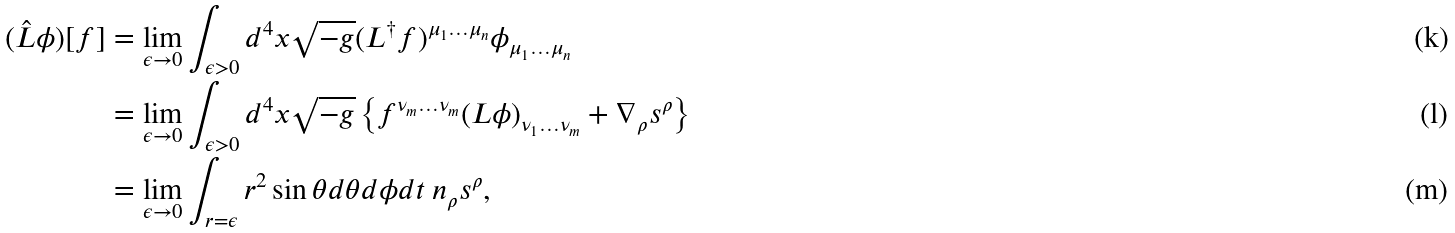Convert formula to latex. <formula><loc_0><loc_0><loc_500><loc_500>( \hat { L } \phi ) [ f ] & = \lim _ { \epsilon \rightarrow 0 } \int _ { \epsilon > 0 } d ^ { 4 } x \sqrt { - g } ( L ^ { \dagger } f ) ^ { \mu _ { 1 } \dots \mu _ { n } } \phi _ { \mu _ { 1 } \dots \mu _ { n } } \\ & = \lim _ { \epsilon \rightarrow 0 } \int _ { \epsilon > 0 } d ^ { 4 } x \sqrt { - g } \left \{ f ^ { \nu _ { m } \dots \nu _ { m } } ( L \phi ) _ { \nu _ { 1 } \dots \nu _ { m } } + \nabla _ { \rho } s ^ { \rho } \right \} \\ & = \lim _ { \epsilon \rightarrow 0 } \int _ { r = \epsilon } r ^ { 2 } \sin \theta d \theta d \phi d t \ n _ { \rho } s ^ { \rho } ,</formula> 